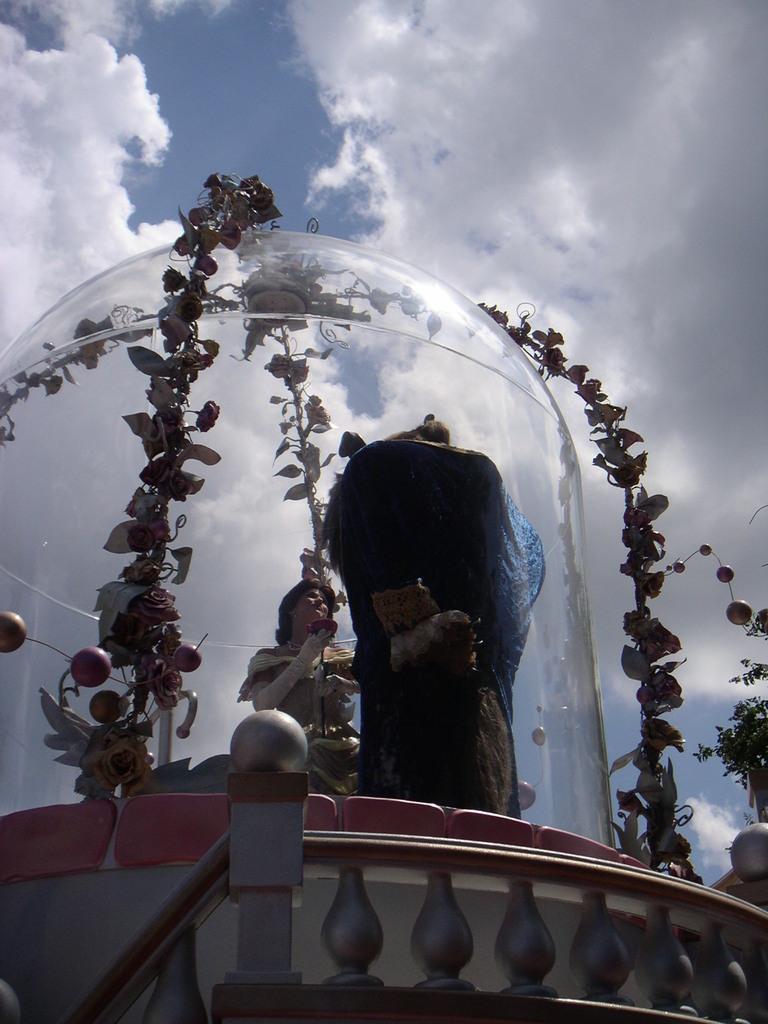Describe this image in one or two sentences. At the bottom of this image there is a railing. Here I can see two statues on the wall. Around the statues there is a glass. On the glass, I can see the artificial creepers. In the background, I can see the sky and clouds. 